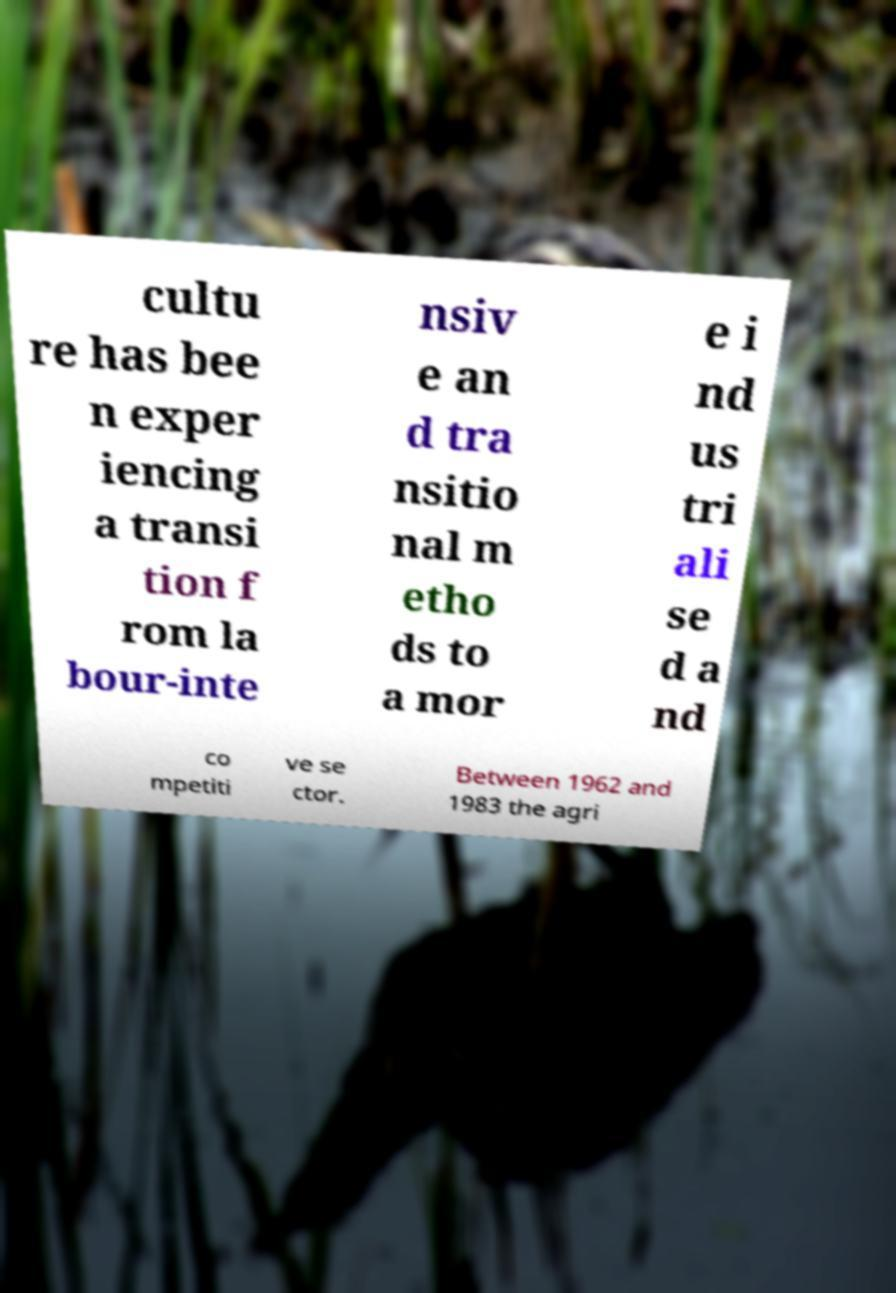Please identify and transcribe the text found in this image. cultu re has bee n exper iencing a transi tion f rom la bour-inte nsiv e an d tra nsitio nal m etho ds to a mor e i nd us tri ali se d a nd co mpetiti ve se ctor. Between 1962 and 1983 the agri 